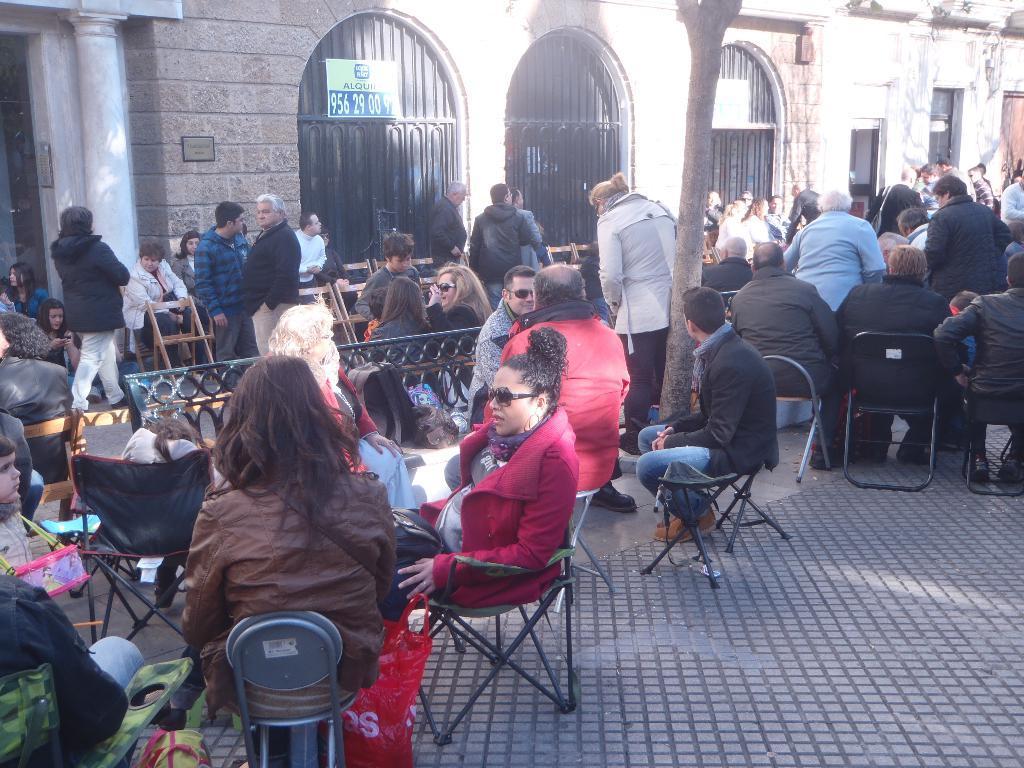How would you summarize this image in a sentence or two? In this picture i could see some persons sitting on the chair standing and talking to each other in the street. In the background i could see the windows which are made of metal and a pillar. 